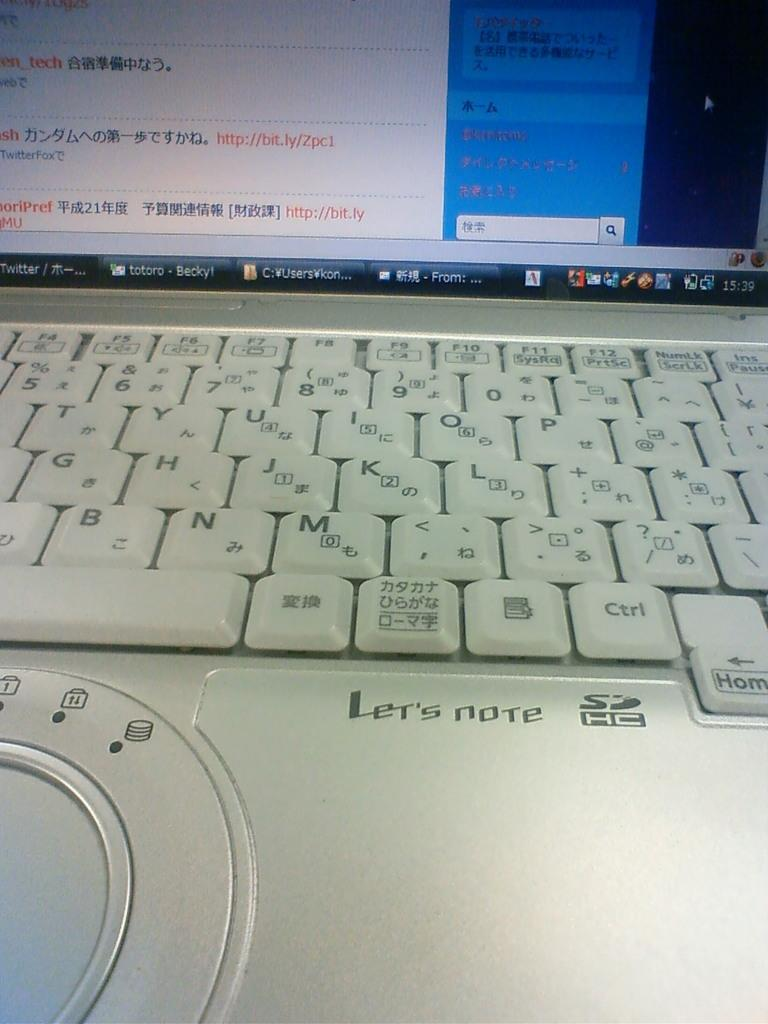<image>
Give a short and clear explanation of the subsequent image. a lap top computer with words Let's Note on it 